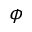<formula> <loc_0><loc_0><loc_500><loc_500>\phi</formula> 